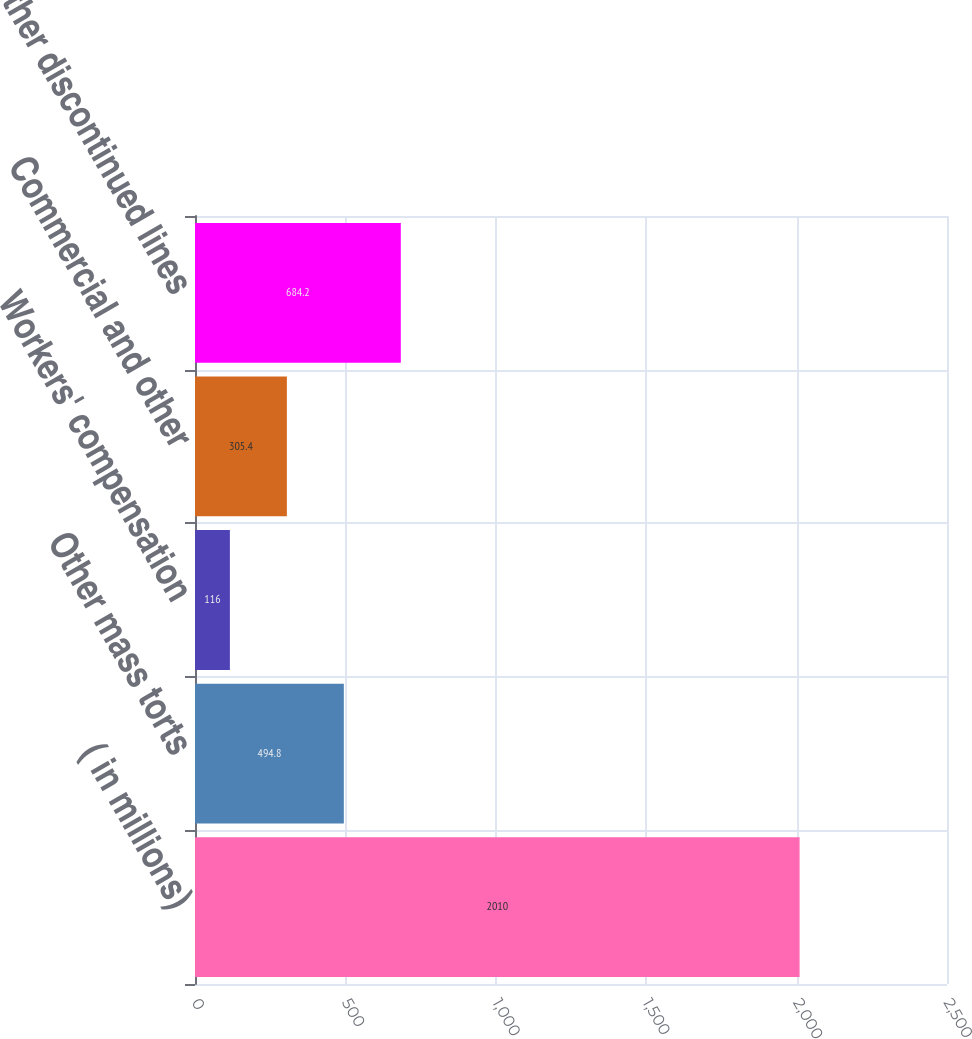<chart> <loc_0><loc_0><loc_500><loc_500><bar_chart><fcel>( in millions)<fcel>Other mass torts<fcel>Workers' compensation<fcel>Commercial and other<fcel>Other discontinued lines<nl><fcel>2010<fcel>494.8<fcel>116<fcel>305.4<fcel>684.2<nl></chart> 